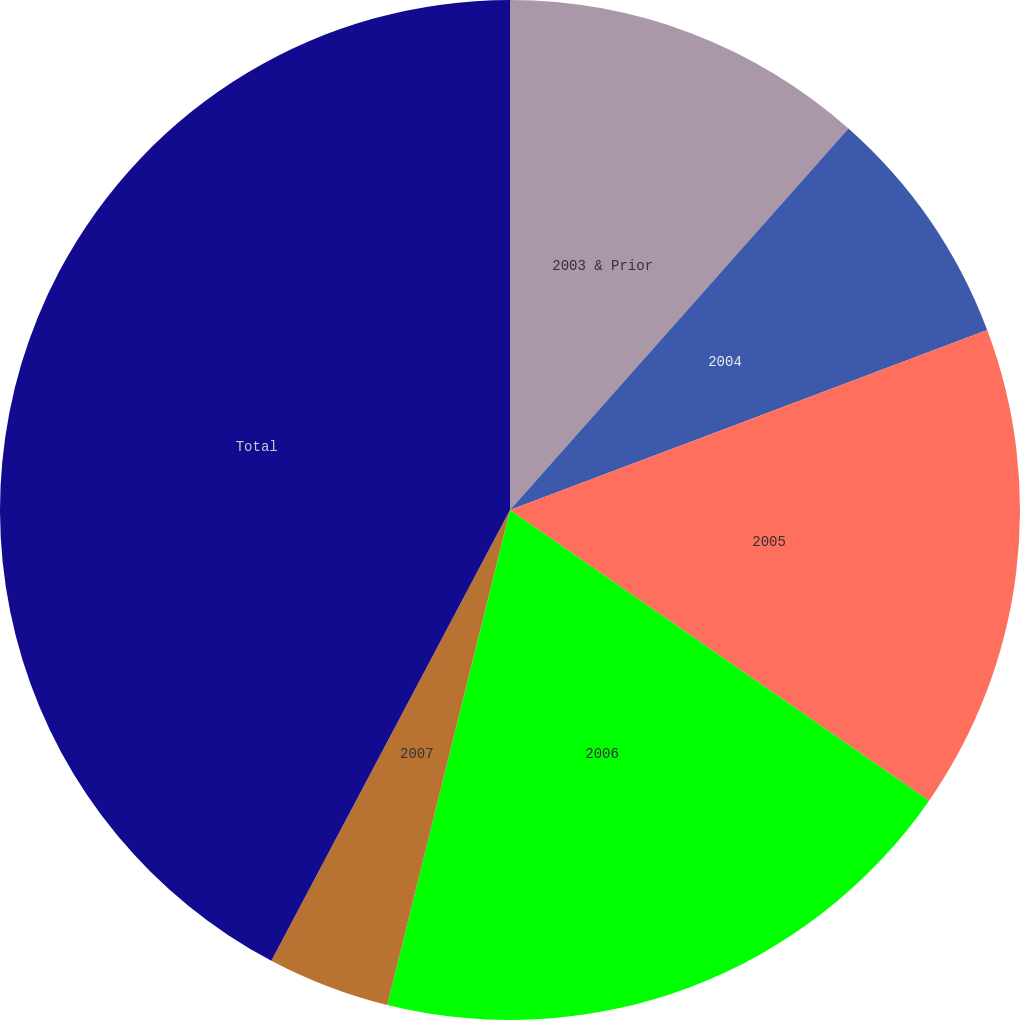Convert chart to OTSL. <chart><loc_0><loc_0><loc_500><loc_500><pie_chart><fcel>2003 & Prior<fcel>2004<fcel>2005<fcel>2006<fcel>2007<fcel>Total<nl><fcel>11.55%<fcel>7.71%<fcel>15.39%<fcel>19.22%<fcel>3.88%<fcel>42.25%<nl></chart> 